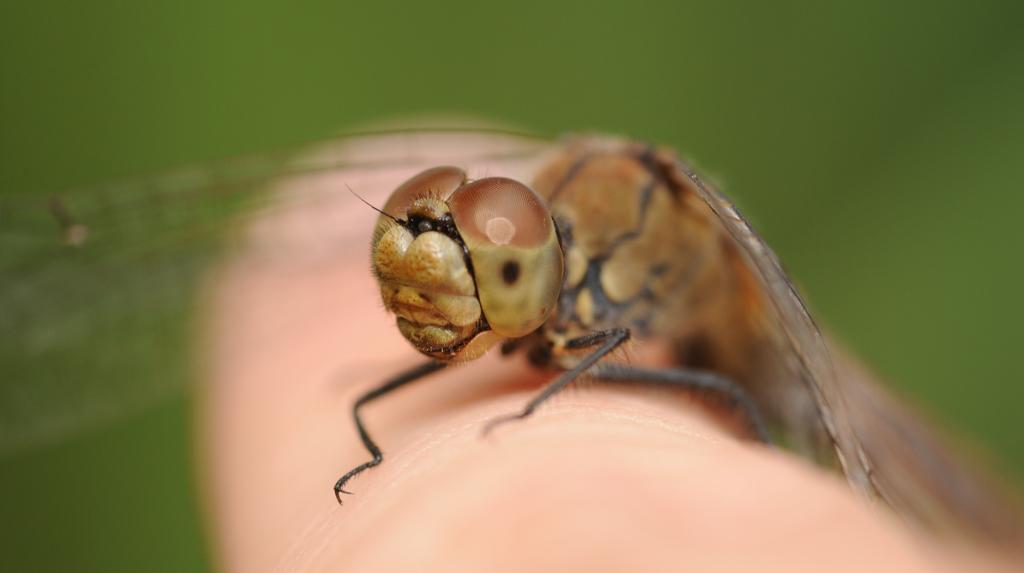Can you describe this image briefly? In the image we can see a insect on a finger. Background of the image is blur. 